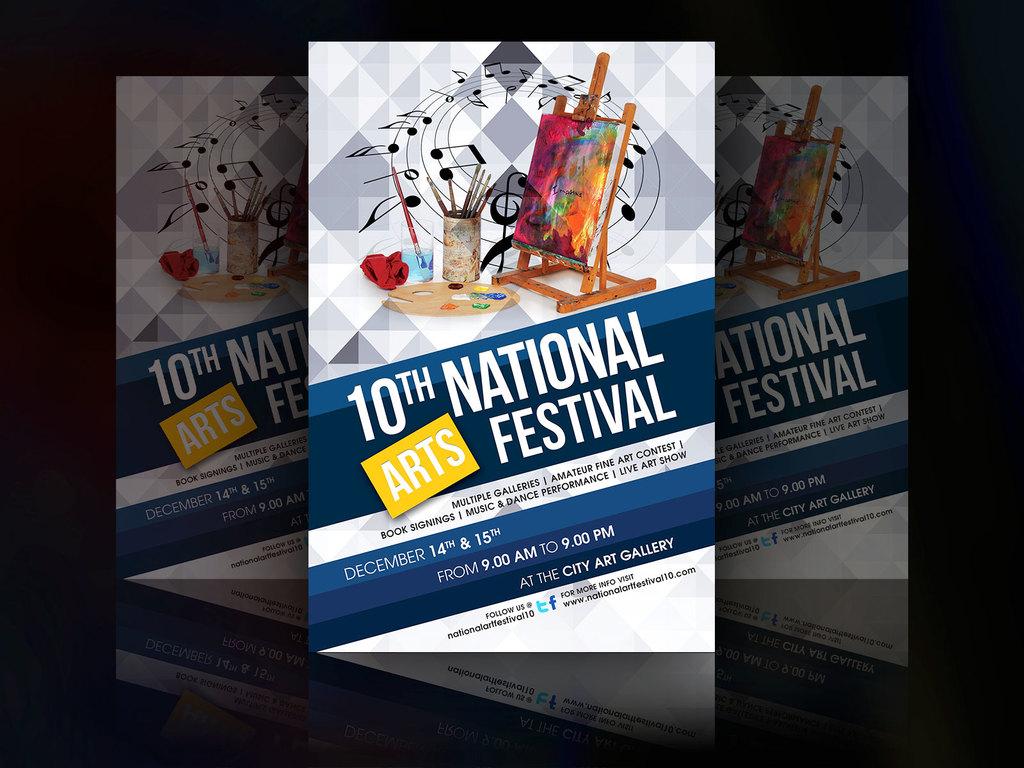What number is the festival now?
Make the answer very short. 10th. When is the event?
Keep it short and to the point. December 14 and 15. 